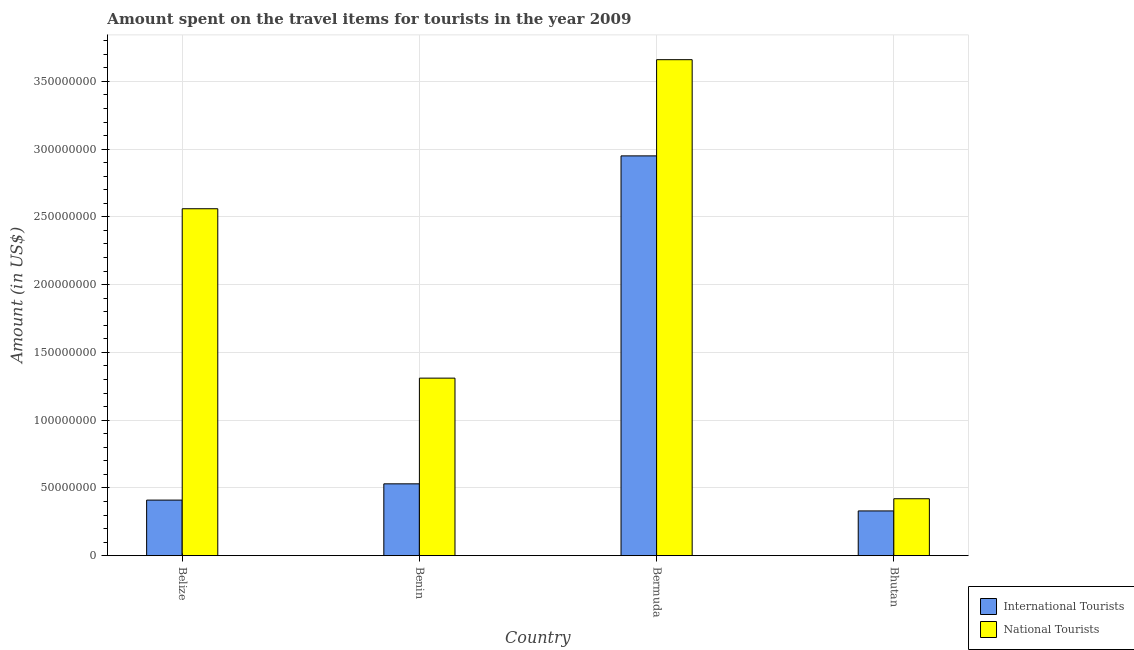Are the number of bars per tick equal to the number of legend labels?
Make the answer very short. Yes. What is the label of the 3rd group of bars from the left?
Keep it short and to the point. Bermuda. In how many cases, is the number of bars for a given country not equal to the number of legend labels?
Make the answer very short. 0. What is the amount spent on travel items of national tourists in Belize?
Give a very brief answer. 2.56e+08. Across all countries, what is the maximum amount spent on travel items of international tourists?
Your answer should be compact. 2.95e+08. Across all countries, what is the minimum amount spent on travel items of international tourists?
Offer a terse response. 3.30e+07. In which country was the amount spent on travel items of national tourists maximum?
Your answer should be compact. Bermuda. In which country was the amount spent on travel items of national tourists minimum?
Your answer should be compact. Bhutan. What is the total amount spent on travel items of international tourists in the graph?
Provide a short and direct response. 4.22e+08. What is the difference between the amount spent on travel items of national tourists in Benin and the amount spent on travel items of international tourists in Belize?
Your answer should be compact. 9.00e+07. What is the average amount spent on travel items of national tourists per country?
Offer a terse response. 1.99e+08. What is the difference between the amount spent on travel items of national tourists and amount spent on travel items of international tourists in Bermuda?
Provide a succinct answer. 7.10e+07. In how many countries, is the amount spent on travel items of international tourists greater than 80000000 US$?
Give a very brief answer. 1. What is the ratio of the amount spent on travel items of national tourists in Bermuda to that in Bhutan?
Your answer should be compact. 8.71. Is the difference between the amount spent on travel items of national tourists in Belize and Bhutan greater than the difference between the amount spent on travel items of international tourists in Belize and Bhutan?
Offer a very short reply. Yes. What is the difference between the highest and the second highest amount spent on travel items of national tourists?
Make the answer very short. 1.10e+08. What is the difference between the highest and the lowest amount spent on travel items of international tourists?
Your answer should be compact. 2.62e+08. Is the sum of the amount spent on travel items of national tourists in Benin and Bermuda greater than the maximum amount spent on travel items of international tourists across all countries?
Your answer should be very brief. Yes. What does the 2nd bar from the left in Benin represents?
Ensure brevity in your answer.  National Tourists. What does the 1st bar from the right in Bermuda represents?
Your answer should be very brief. National Tourists. Are all the bars in the graph horizontal?
Make the answer very short. No. What is the difference between two consecutive major ticks on the Y-axis?
Give a very brief answer. 5.00e+07. Are the values on the major ticks of Y-axis written in scientific E-notation?
Keep it short and to the point. No. Where does the legend appear in the graph?
Provide a succinct answer. Bottom right. How many legend labels are there?
Keep it short and to the point. 2. What is the title of the graph?
Your answer should be very brief. Amount spent on the travel items for tourists in the year 2009. Does "IMF concessional" appear as one of the legend labels in the graph?
Provide a succinct answer. No. What is the label or title of the X-axis?
Ensure brevity in your answer.  Country. What is the label or title of the Y-axis?
Offer a terse response. Amount (in US$). What is the Amount (in US$) of International Tourists in Belize?
Provide a succinct answer. 4.10e+07. What is the Amount (in US$) of National Tourists in Belize?
Ensure brevity in your answer.  2.56e+08. What is the Amount (in US$) of International Tourists in Benin?
Your answer should be compact. 5.30e+07. What is the Amount (in US$) of National Tourists in Benin?
Provide a short and direct response. 1.31e+08. What is the Amount (in US$) of International Tourists in Bermuda?
Provide a short and direct response. 2.95e+08. What is the Amount (in US$) of National Tourists in Bermuda?
Provide a succinct answer. 3.66e+08. What is the Amount (in US$) of International Tourists in Bhutan?
Your response must be concise. 3.30e+07. What is the Amount (in US$) in National Tourists in Bhutan?
Provide a short and direct response. 4.20e+07. Across all countries, what is the maximum Amount (in US$) of International Tourists?
Make the answer very short. 2.95e+08. Across all countries, what is the maximum Amount (in US$) of National Tourists?
Offer a terse response. 3.66e+08. Across all countries, what is the minimum Amount (in US$) of International Tourists?
Give a very brief answer. 3.30e+07. Across all countries, what is the minimum Amount (in US$) of National Tourists?
Give a very brief answer. 4.20e+07. What is the total Amount (in US$) in International Tourists in the graph?
Give a very brief answer. 4.22e+08. What is the total Amount (in US$) of National Tourists in the graph?
Your answer should be compact. 7.95e+08. What is the difference between the Amount (in US$) in International Tourists in Belize and that in Benin?
Keep it short and to the point. -1.20e+07. What is the difference between the Amount (in US$) of National Tourists in Belize and that in Benin?
Your answer should be very brief. 1.25e+08. What is the difference between the Amount (in US$) of International Tourists in Belize and that in Bermuda?
Your answer should be very brief. -2.54e+08. What is the difference between the Amount (in US$) in National Tourists in Belize and that in Bermuda?
Keep it short and to the point. -1.10e+08. What is the difference between the Amount (in US$) in International Tourists in Belize and that in Bhutan?
Your answer should be very brief. 8.00e+06. What is the difference between the Amount (in US$) of National Tourists in Belize and that in Bhutan?
Your answer should be very brief. 2.14e+08. What is the difference between the Amount (in US$) in International Tourists in Benin and that in Bermuda?
Provide a short and direct response. -2.42e+08. What is the difference between the Amount (in US$) of National Tourists in Benin and that in Bermuda?
Offer a very short reply. -2.35e+08. What is the difference between the Amount (in US$) of International Tourists in Benin and that in Bhutan?
Your answer should be very brief. 2.00e+07. What is the difference between the Amount (in US$) of National Tourists in Benin and that in Bhutan?
Your response must be concise. 8.90e+07. What is the difference between the Amount (in US$) of International Tourists in Bermuda and that in Bhutan?
Ensure brevity in your answer.  2.62e+08. What is the difference between the Amount (in US$) of National Tourists in Bermuda and that in Bhutan?
Your answer should be very brief. 3.24e+08. What is the difference between the Amount (in US$) in International Tourists in Belize and the Amount (in US$) in National Tourists in Benin?
Keep it short and to the point. -9.00e+07. What is the difference between the Amount (in US$) in International Tourists in Belize and the Amount (in US$) in National Tourists in Bermuda?
Offer a very short reply. -3.25e+08. What is the difference between the Amount (in US$) of International Tourists in Belize and the Amount (in US$) of National Tourists in Bhutan?
Your answer should be compact. -1.00e+06. What is the difference between the Amount (in US$) of International Tourists in Benin and the Amount (in US$) of National Tourists in Bermuda?
Your response must be concise. -3.13e+08. What is the difference between the Amount (in US$) in International Tourists in Benin and the Amount (in US$) in National Tourists in Bhutan?
Make the answer very short. 1.10e+07. What is the difference between the Amount (in US$) in International Tourists in Bermuda and the Amount (in US$) in National Tourists in Bhutan?
Offer a very short reply. 2.53e+08. What is the average Amount (in US$) of International Tourists per country?
Provide a succinct answer. 1.06e+08. What is the average Amount (in US$) of National Tourists per country?
Give a very brief answer. 1.99e+08. What is the difference between the Amount (in US$) in International Tourists and Amount (in US$) in National Tourists in Belize?
Your response must be concise. -2.15e+08. What is the difference between the Amount (in US$) in International Tourists and Amount (in US$) in National Tourists in Benin?
Your response must be concise. -7.80e+07. What is the difference between the Amount (in US$) of International Tourists and Amount (in US$) of National Tourists in Bermuda?
Make the answer very short. -7.10e+07. What is the difference between the Amount (in US$) in International Tourists and Amount (in US$) in National Tourists in Bhutan?
Offer a terse response. -9.00e+06. What is the ratio of the Amount (in US$) in International Tourists in Belize to that in Benin?
Ensure brevity in your answer.  0.77. What is the ratio of the Amount (in US$) in National Tourists in Belize to that in Benin?
Provide a short and direct response. 1.95. What is the ratio of the Amount (in US$) of International Tourists in Belize to that in Bermuda?
Provide a short and direct response. 0.14. What is the ratio of the Amount (in US$) of National Tourists in Belize to that in Bermuda?
Your response must be concise. 0.7. What is the ratio of the Amount (in US$) of International Tourists in Belize to that in Bhutan?
Offer a terse response. 1.24. What is the ratio of the Amount (in US$) in National Tourists in Belize to that in Bhutan?
Your answer should be compact. 6.1. What is the ratio of the Amount (in US$) in International Tourists in Benin to that in Bermuda?
Your response must be concise. 0.18. What is the ratio of the Amount (in US$) in National Tourists in Benin to that in Bermuda?
Provide a succinct answer. 0.36. What is the ratio of the Amount (in US$) in International Tourists in Benin to that in Bhutan?
Offer a terse response. 1.61. What is the ratio of the Amount (in US$) of National Tourists in Benin to that in Bhutan?
Ensure brevity in your answer.  3.12. What is the ratio of the Amount (in US$) in International Tourists in Bermuda to that in Bhutan?
Your answer should be very brief. 8.94. What is the ratio of the Amount (in US$) in National Tourists in Bermuda to that in Bhutan?
Your answer should be very brief. 8.71. What is the difference between the highest and the second highest Amount (in US$) of International Tourists?
Your response must be concise. 2.42e+08. What is the difference between the highest and the second highest Amount (in US$) in National Tourists?
Your answer should be compact. 1.10e+08. What is the difference between the highest and the lowest Amount (in US$) of International Tourists?
Ensure brevity in your answer.  2.62e+08. What is the difference between the highest and the lowest Amount (in US$) in National Tourists?
Ensure brevity in your answer.  3.24e+08. 